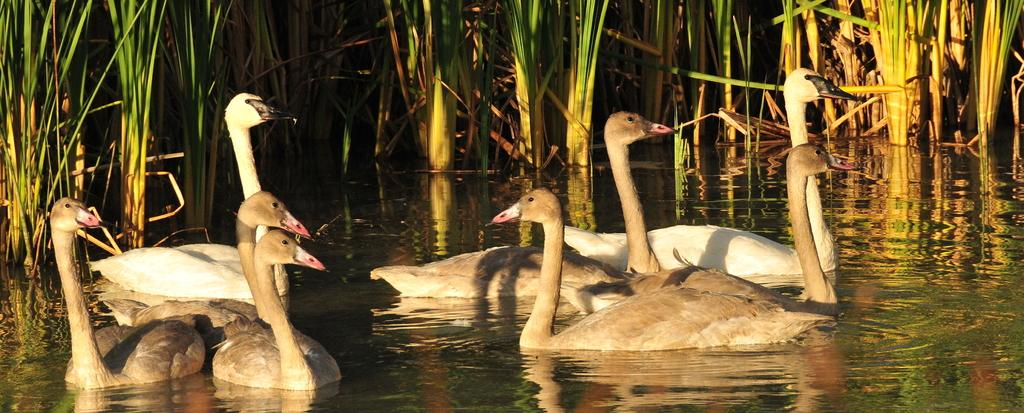What type of animals can be seen in the water in the image? There are swans in the water in the image. What else can be seen in the water besides the swans? There are plants in the water, extending from left to right. What riddle can be solved by the swans in the image? There is no riddle present in the image, nor is there any indication that the swans are involved in solving one. 